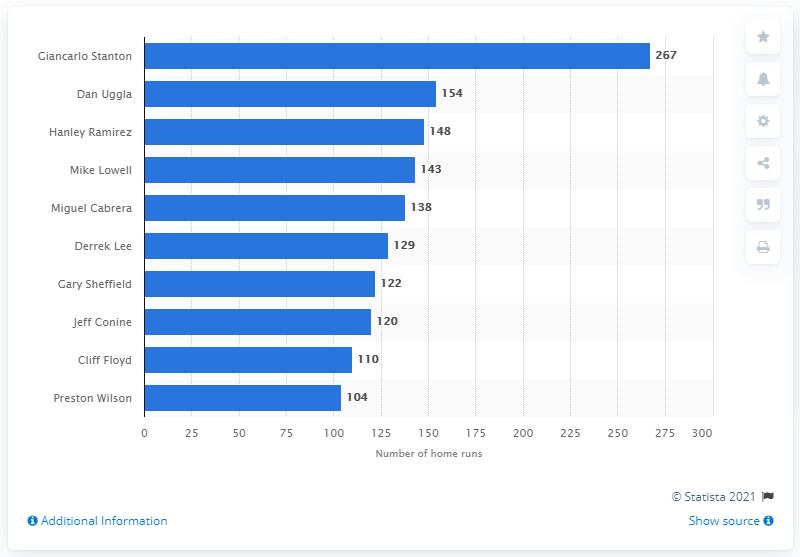List a handful of essential elements in this visual. Giancarlo Stanton has hit the most home runs in Miami Marlins franchise history. Giancarlo Stanton has hit a staggering 267 home runs. 